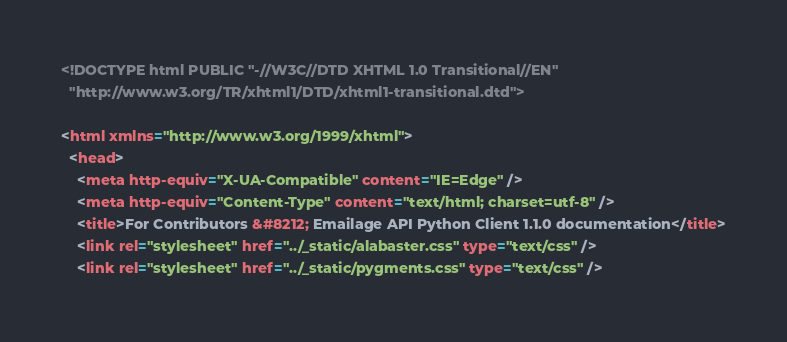<code> <loc_0><loc_0><loc_500><loc_500><_HTML_>
<!DOCTYPE html PUBLIC "-//W3C//DTD XHTML 1.0 Transitional//EN"
  "http://www.w3.org/TR/xhtml1/DTD/xhtml1-transitional.dtd">

<html xmlns="http://www.w3.org/1999/xhtml">
  <head>
    <meta http-equiv="X-UA-Compatible" content="IE=Edge" />
    <meta http-equiv="Content-Type" content="text/html; charset=utf-8" />
    <title>For Contributors &#8212; Emailage API Python Client 1.1.0 documentation</title>
    <link rel="stylesheet" href="../_static/alabaster.css" type="text/css" />
    <link rel="stylesheet" href="../_static/pygments.css" type="text/css" /></code> 